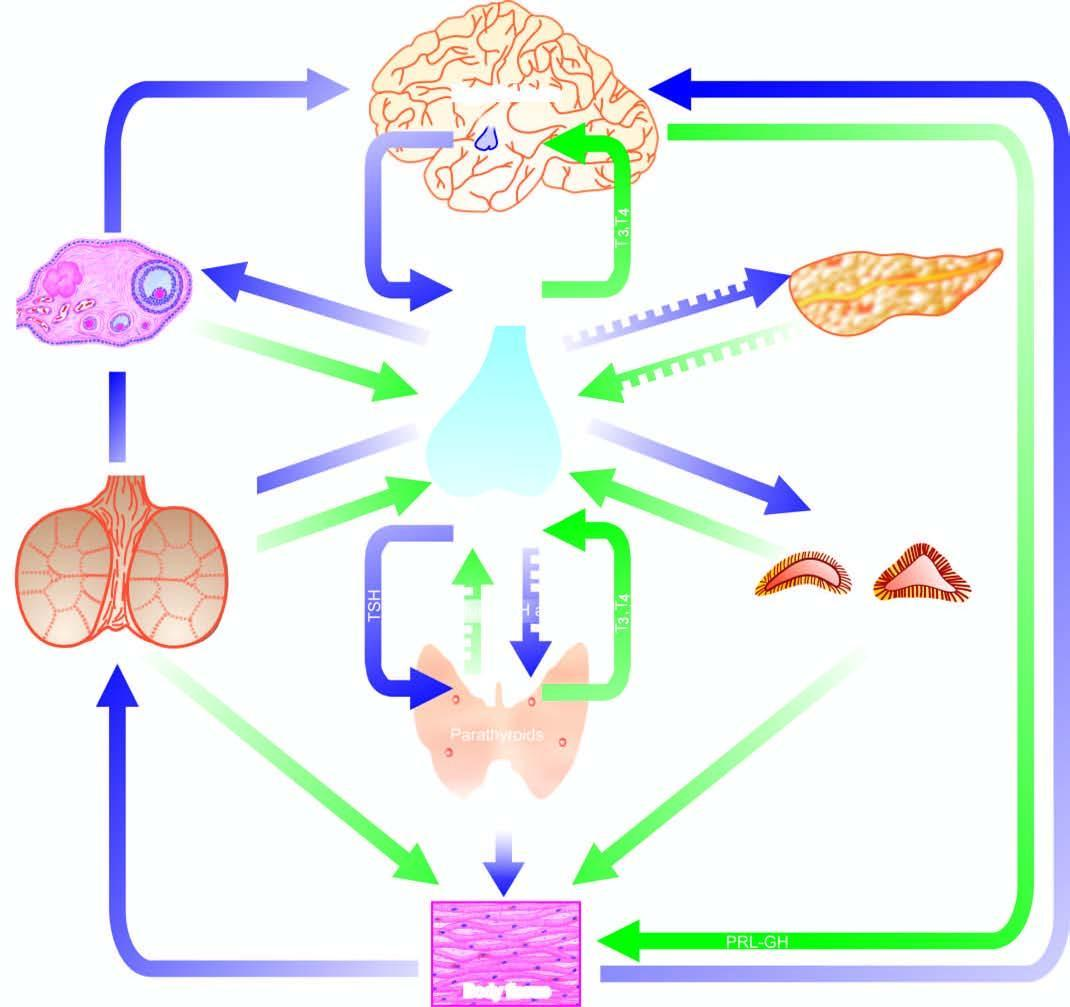do the lumen exist for each endocrine gland having a regulating hormone?
Answer the question using a single word or phrase. No 